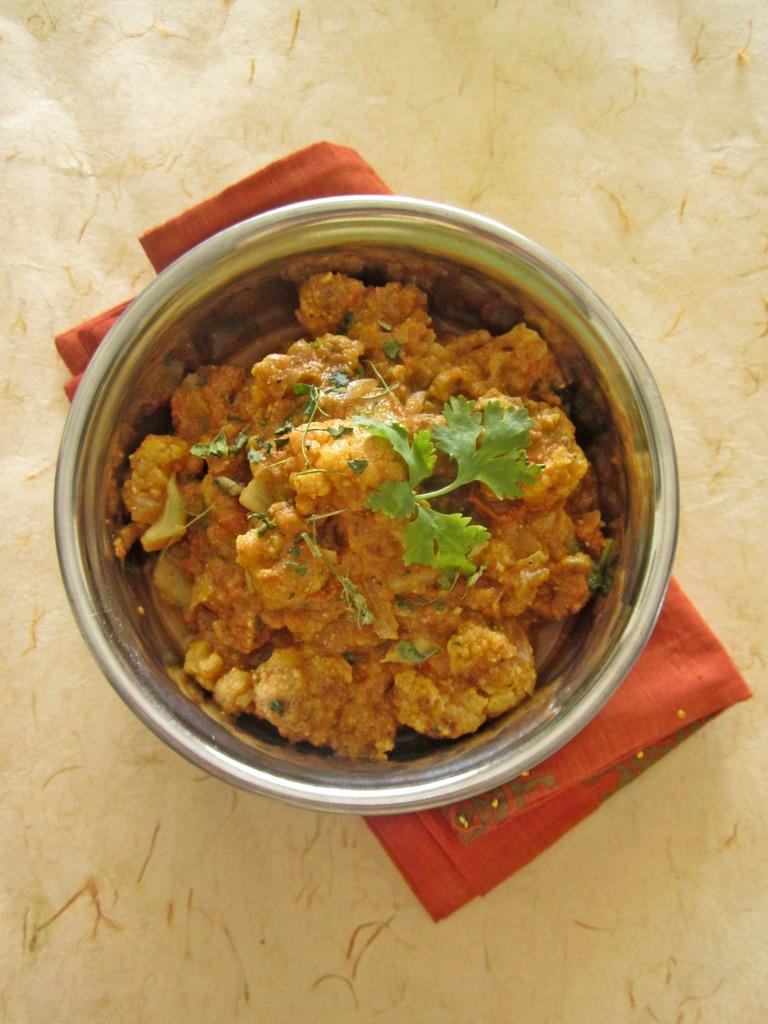What is in the bowl that is visible in the image? There is a bowl with food items in the image. What is the bowl placed on? The bowl is on a red cloth. What color is the cloth in the background of the image? The background of the image contains a white color cloth. Can you see a frog making a decision with a piece of chalk in the image? No, there is no frog or chalk present in the image. 